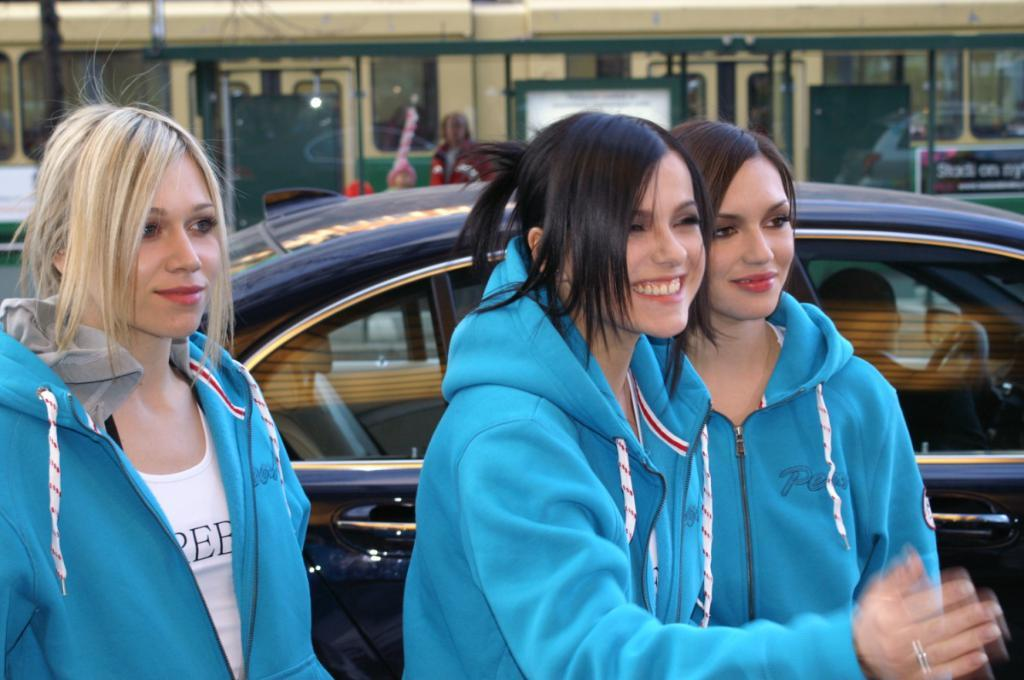How many women are in the image? There are three women in the image. What are the women wearing? The women are wearing blue color jackets. What expression do the women have? The women are smiling. In which direction are the women looking? The women are looking at the right side. What can be seen in the background of the image? There is a car and a train in the background of the image. What type of muscle can be seen flexing on the women's arms in the image? There is no muscle flexing visible on the women's arms in the image. How many wings are present on the women in the image? There are no wings present on the women in the image. 